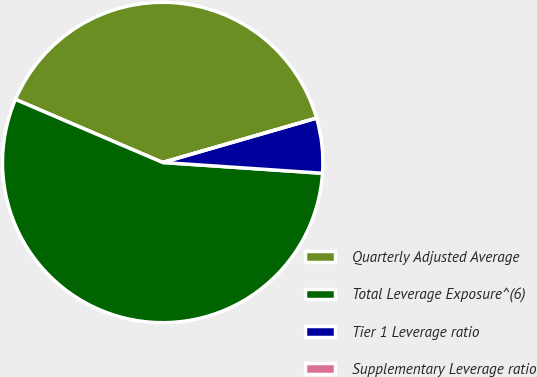Convert chart to OTSL. <chart><loc_0><loc_0><loc_500><loc_500><pie_chart><fcel>Quarterly Adjusted Average<fcel>Total Leverage Exposure^(6)<fcel>Tier 1 Leverage ratio<fcel>Supplementary Leverage ratio<nl><fcel>39.09%<fcel>55.37%<fcel>5.54%<fcel>0.0%<nl></chart> 